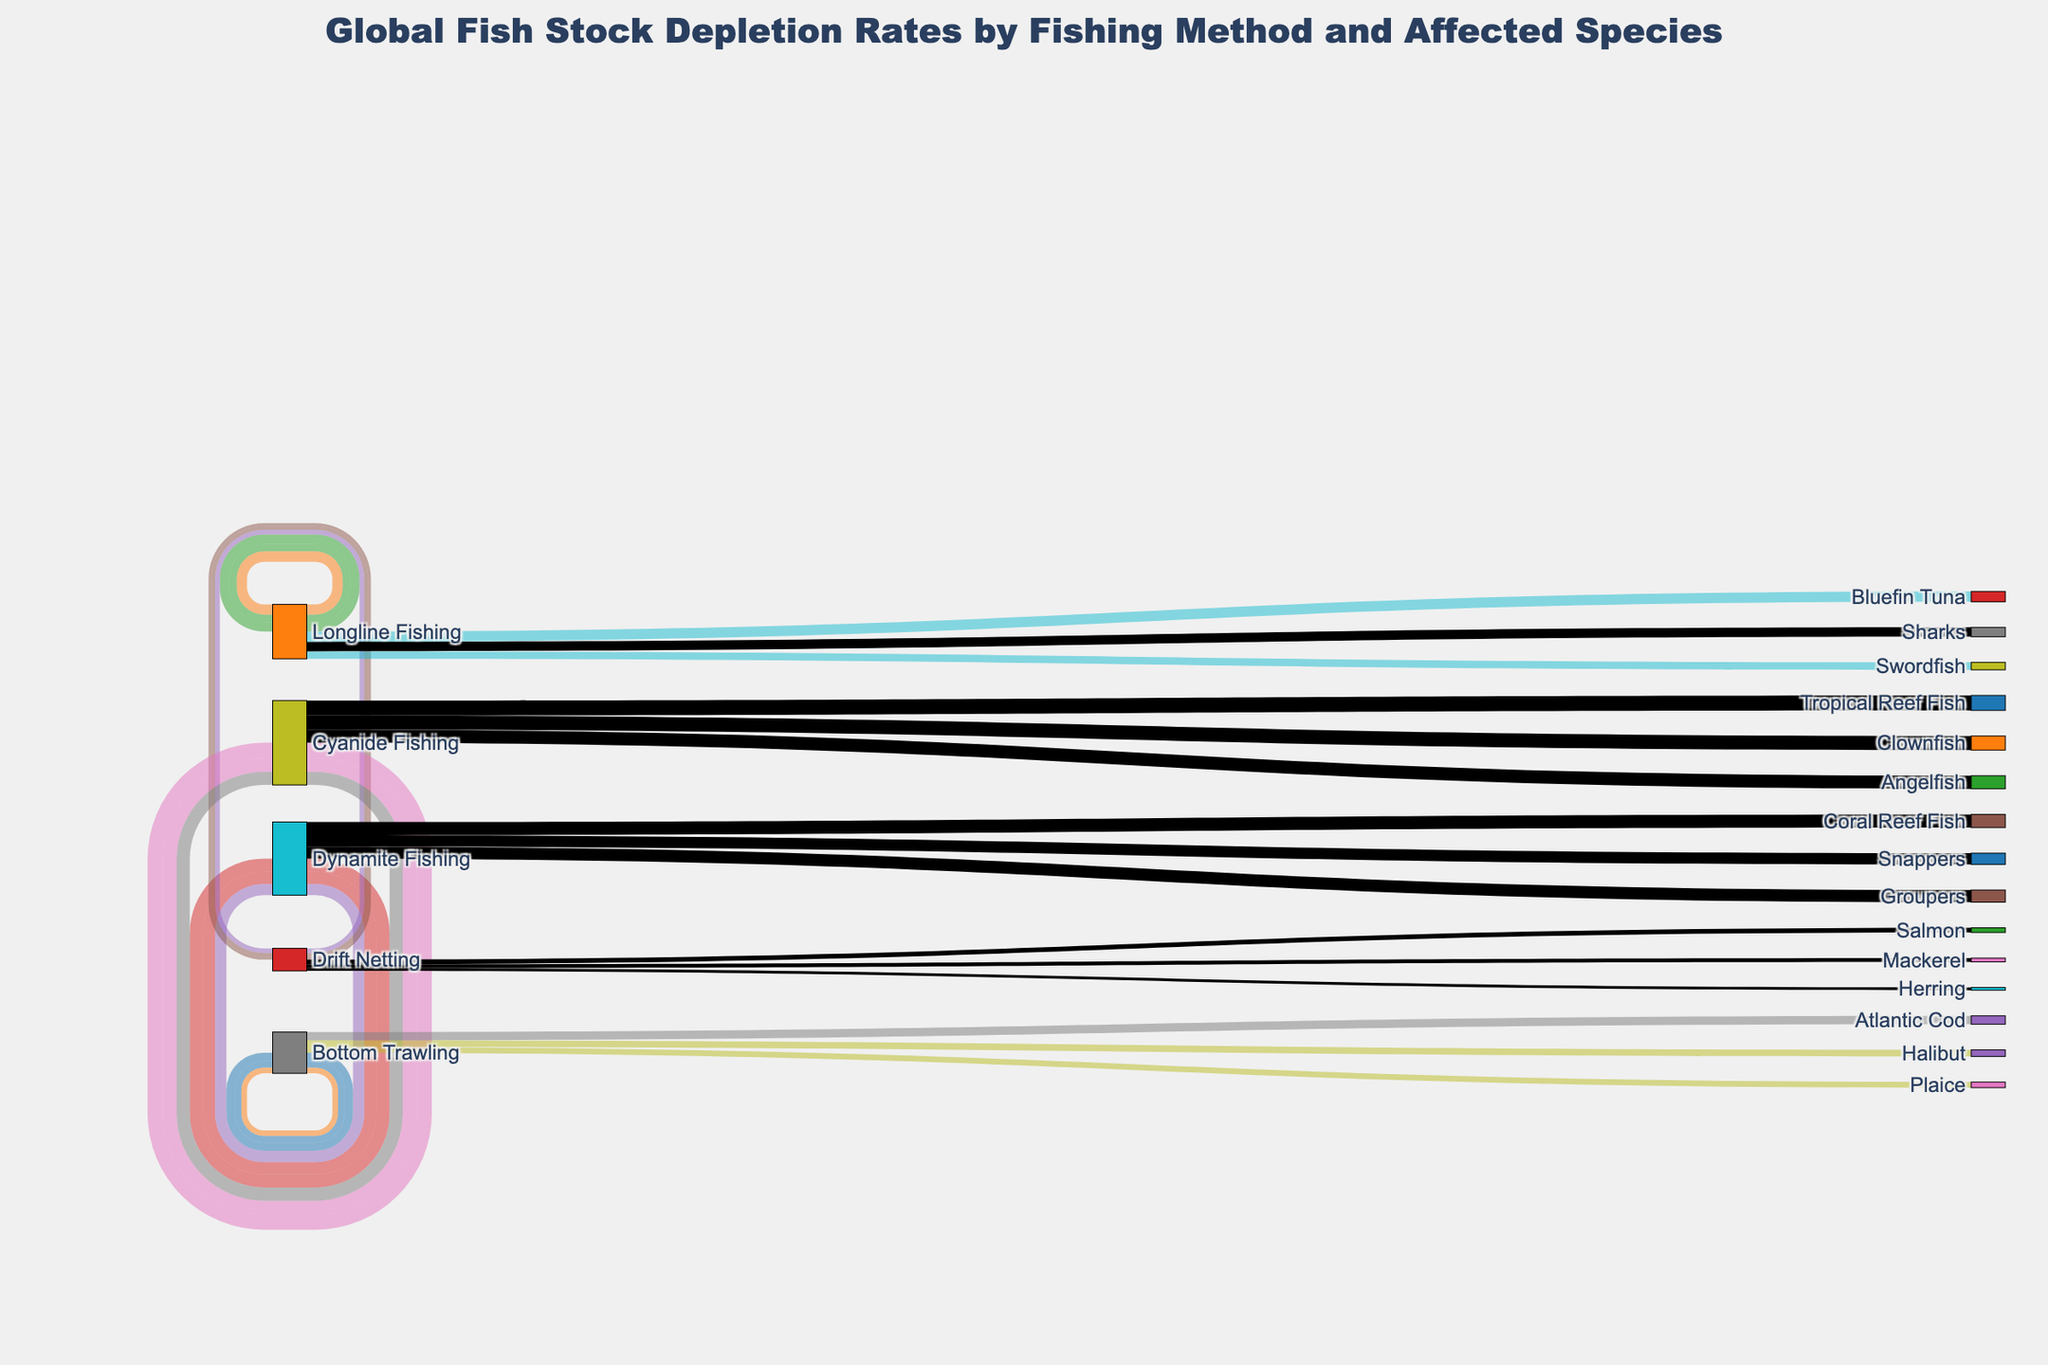What's the title of the figure? The title is typically located at the top of the figure. By reading the title directly from this placement, we can identify it.
Answer: Global Fish Stock Depletion Rates by Fishing Method and Affected Species How many fishing methods are shown in the figure? By observing each unique method label under the "Method" category in the Sankey diagram, we can count the distinct methods.
Answer: Five Which fishing method shows the highest depletion rate for any species? By looking at the values next to the links between methods and species, we can pinpoint the highest value. In this case, it's Dynamite Fishing with Coral Reef Fish at 70%.
Answer: Dynamite Fishing with Coral Reef Fish What is the total depletion rate for species affected by Longline Fishing? We sum the depletion rates of Bluefin Tuna, Swordfish, and Sharks under Longline Fishing: 55% + 40% + 50%.
Answer: 145% What is the average depletion rate of species affected by Bottom Trawling? The depletion rates for Atlantic Cod, Halibut, and Plaice are 45%, 35%, and 30% respectively. Sum them up and divide by the number of species: (45% + 35% + 30%) / 3.
Answer: 36.67% Which method affects the highest number of species in total? Count the number of species linked to each fishing method, and the method with the most connections is the answer.
Answer: Dynamite Fishing with three species Comparing the depletion rates of Bottom Trawling and Dynamite Fishing, which has a higher overall impact on their respective species? Sum the depletion rates of species affected by each method. Bottom Trawling: 45% + 35% + 30% = 110%. Dynamite Fishing: 70% + 65% + 60% = 195%.
Answer: Dynamite Fishing Which fishing method has the least impact on its linked species, based on the lowest depletion rate recorded? The lowest depletion rate can be found by identifying the smallest percentage value among all methods. Drift Netting affects Herring at 15%, which is the lowest value in the diagram.
Answer: Drift Netting 